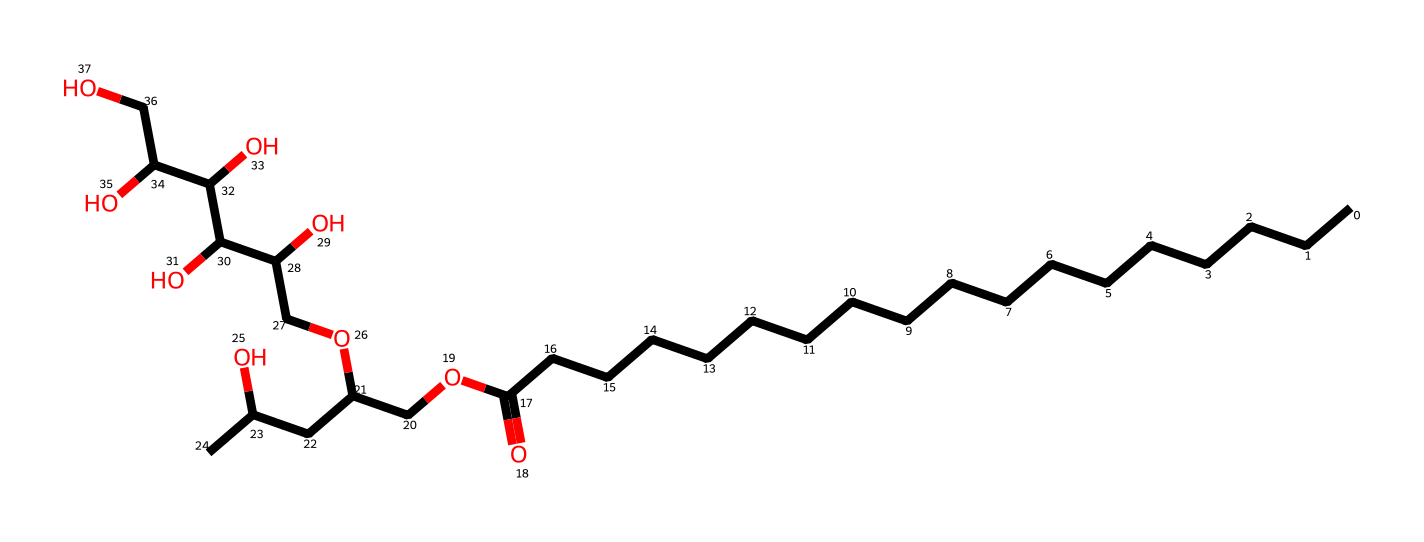how many carbon atoms are in this molecule? By analyzing the provided SMILES representation, I count the "C" symbols. There are 20 carbon (C) atoms in the long carbon chain and branched structures.
Answer: 20 how many hydroxyl (OH) groups are present in the structure? The hydroxyl groups in the molecule correspond to each "O" that is specifically associated with a "C" in the structure. Counting these, there are 5 hydroxyl groups present.
Answer: 5 what is the functional group present at the end of the carbon chain? The functional group indicated by "O" followed by "CC" after "CCCCCCCCCCCCCCCCCC(=O)" suggests a carboxylic acid. The presence of the "=O" indicates a carbonyl, implying it is a carboxylate.
Answer: carboxylic acid what type of surfactant is polysorbate 20? Polysorbate 20 is classified as a nonionic surfactant due to the presence of ether and hydroxyl groups, which do not carry a charge.
Answer: nonionic what property does the long hydrocarbon chain provide to this molecule? The long hydrocarbon chain provides lipophilicity, allowing the molecule to interact with and dissolve nonpolar substances effectively.
Answer: lipophilicity how does the structure contribute to emulsifying ability? The structure contains both hydrophilic regions (due to hydroxyl groups) and a hydrophobic tail (the long carbon chain), allowing it to stabilize emulsions by reducing the surface tension between oil and water phases.
Answer: stabilizes emulsions 